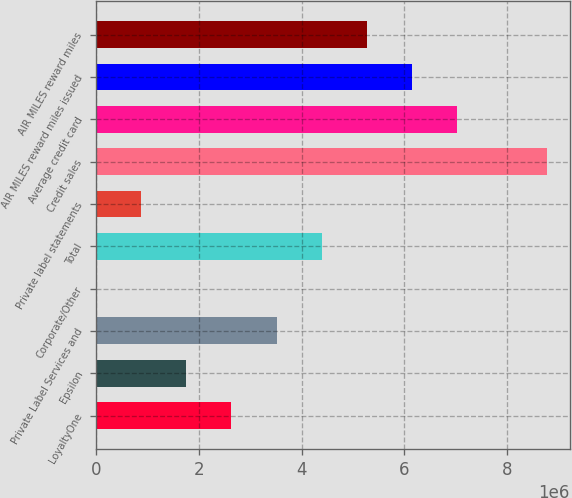Convert chart to OTSL. <chart><loc_0><loc_0><loc_500><loc_500><bar_chart><fcel>LoyaltyOne<fcel>Epsilon<fcel>Private Label Services and<fcel>Corporate/Other<fcel>Total<fcel>Private label statements<fcel>Credit sales<fcel>Average credit card<fcel>AIR MILES reward miles issued<fcel>AIR MILES reward miles<nl><fcel>2.63334e+06<fcel>1.75618e+06<fcel>3.51049e+06<fcel>1866<fcel>4.38765e+06<fcel>879023<fcel>8.77344e+06<fcel>7.01912e+06<fcel>6.14196e+06<fcel>5.26481e+06<nl></chart> 